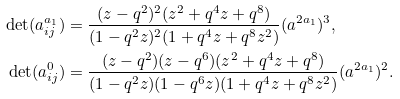Convert formula to latex. <formula><loc_0><loc_0><loc_500><loc_500>\det ( a ^ { \L a _ { 1 } } _ { i j } ) & = \frac { ( z - q ^ { 2 } ) ^ { 2 } ( z ^ { 2 } + q ^ { 4 } z + q ^ { 8 } ) } { ( 1 - q ^ { 2 } z ) ^ { 2 } ( 1 + q ^ { 4 } z + q ^ { 8 } z ^ { 2 } ) } ( a ^ { 2 \L a _ { 1 } } ) ^ { 3 } , \\ \det ( a ^ { 0 } _ { i j } ) & = \frac { ( z - q ^ { 2 } ) ( z - q ^ { 6 } ) ( z ^ { 2 } + q ^ { 4 } z + q ^ { 8 } ) } { ( 1 - q ^ { 2 } z ) ( 1 - q ^ { 6 } z ) ( 1 + q ^ { 4 } z + q ^ { 8 } z ^ { 2 } ) } ( a ^ { 2 \L a _ { 1 } } ) ^ { 2 } .</formula> 